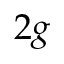<formula> <loc_0><loc_0><loc_500><loc_500>2 g</formula> 